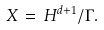Convert formula to latex. <formula><loc_0><loc_0><loc_500><loc_500>X \, = \, { H } ^ { d + 1 } / \Gamma .</formula> 